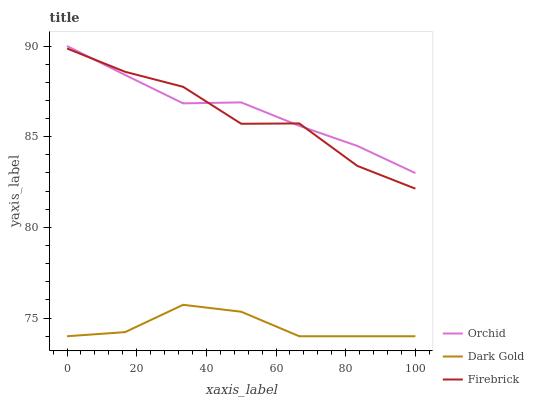Does Dark Gold have the minimum area under the curve?
Answer yes or no. Yes. Does Orchid have the maximum area under the curve?
Answer yes or no. Yes. Does Orchid have the minimum area under the curve?
Answer yes or no. No. Does Dark Gold have the maximum area under the curve?
Answer yes or no. No. Is Orchid the smoothest?
Answer yes or no. Yes. Is Firebrick the roughest?
Answer yes or no. Yes. Is Dark Gold the smoothest?
Answer yes or no. No. Is Dark Gold the roughest?
Answer yes or no. No. Does Dark Gold have the lowest value?
Answer yes or no. Yes. Does Orchid have the lowest value?
Answer yes or no. No. Does Orchid have the highest value?
Answer yes or no. Yes. Does Dark Gold have the highest value?
Answer yes or no. No. Is Dark Gold less than Orchid?
Answer yes or no. Yes. Is Orchid greater than Dark Gold?
Answer yes or no. Yes. Does Firebrick intersect Orchid?
Answer yes or no. Yes. Is Firebrick less than Orchid?
Answer yes or no. No. Is Firebrick greater than Orchid?
Answer yes or no. No. Does Dark Gold intersect Orchid?
Answer yes or no. No. 